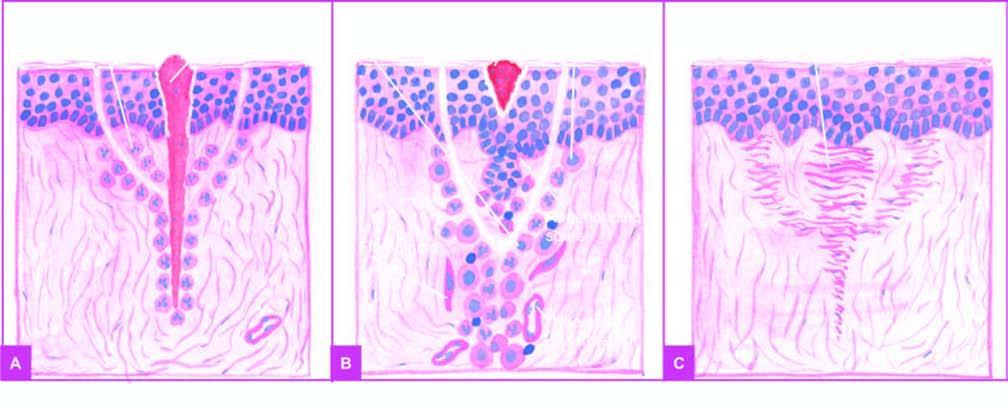where is inflammatory response from?
Answer the question using a single word or phrase. The margins 